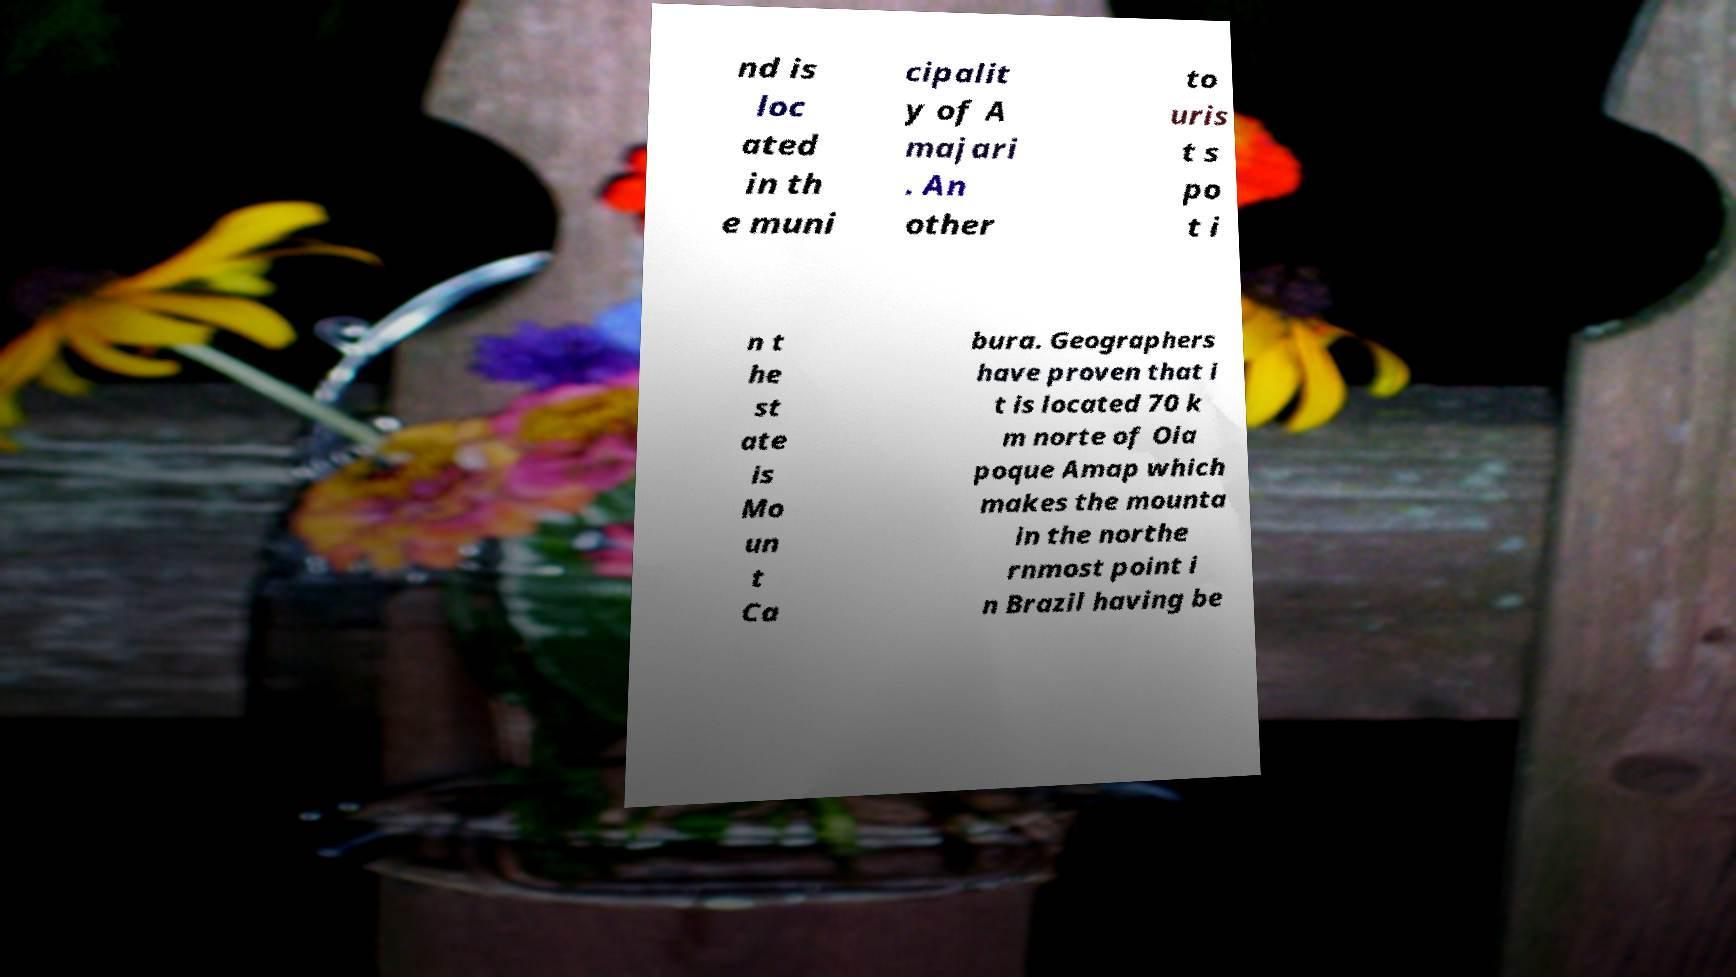I need the written content from this picture converted into text. Can you do that? nd is loc ated in th e muni cipalit y of A majari . An other to uris t s po t i n t he st ate is Mo un t Ca bura. Geographers have proven that i t is located 70 k m norte of Oia poque Amap which makes the mounta in the northe rnmost point i n Brazil having be 